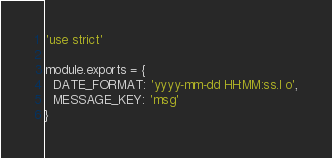<code> <loc_0><loc_0><loc_500><loc_500><_JavaScript_>'use strict'

module.exports = {
  DATE_FORMAT: 'yyyy-mm-dd HH:MM:ss.l o',
  MESSAGE_KEY: 'msg'
}
</code> 